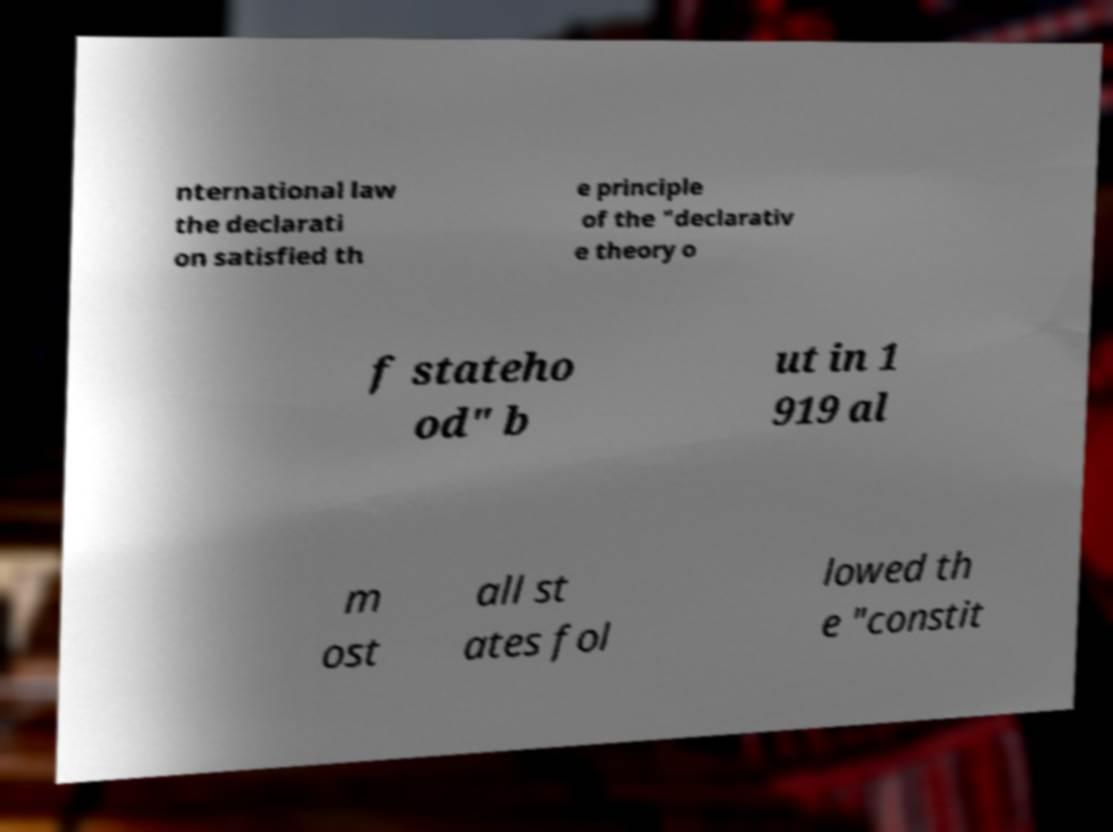Please identify and transcribe the text found in this image. nternational law the declarati on satisfied th e principle of the "declarativ e theory o f stateho od" b ut in 1 919 al m ost all st ates fol lowed th e "constit 